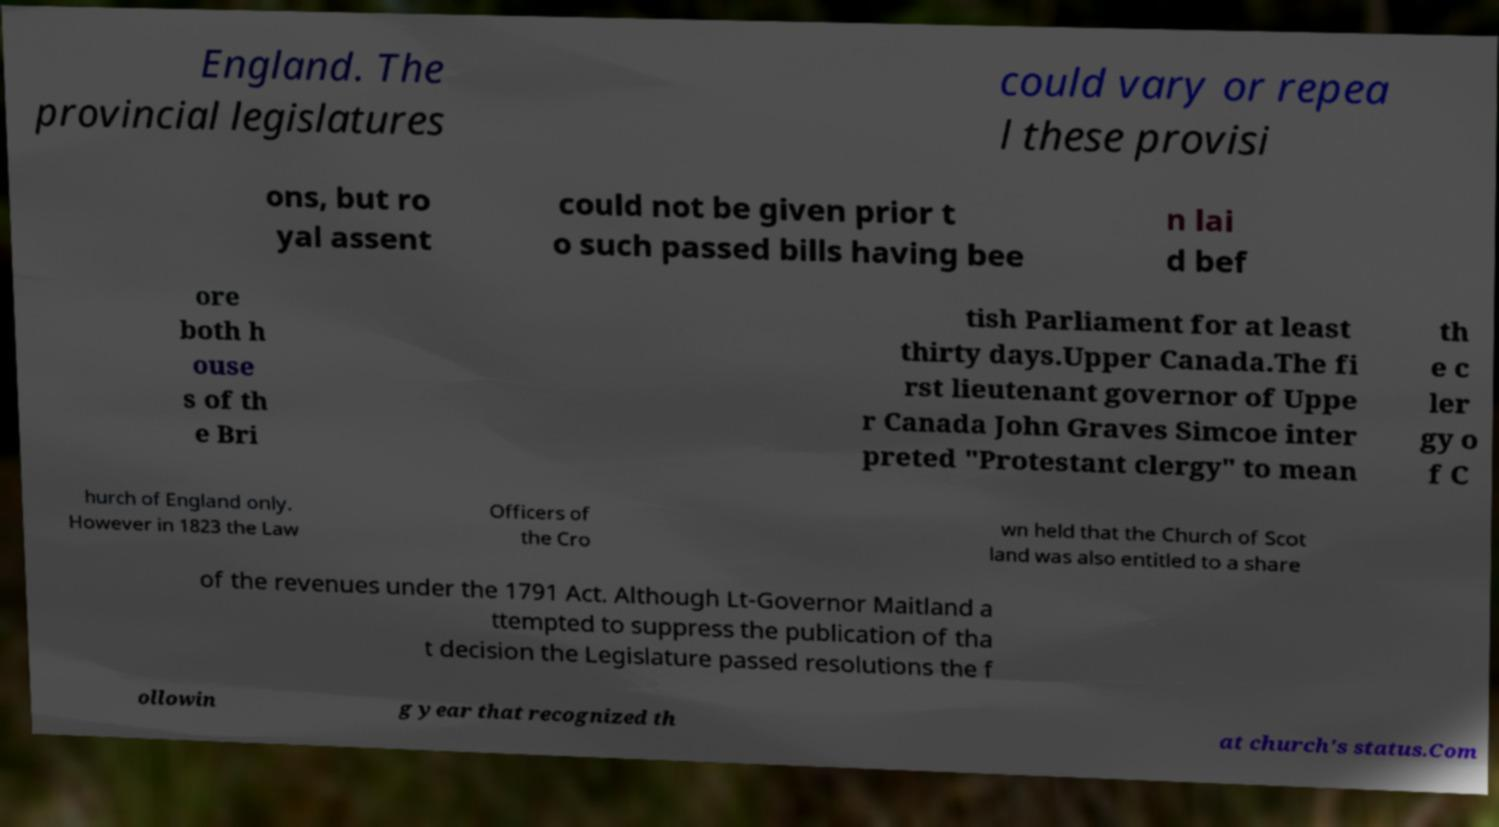I need the written content from this picture converted into text. Can you do that? England. The provincial legislatures could vary or repea l these provisi ons, but ro yal assent could not be given prior t o such passed bills having bee n lai d bef ore both h ouse s of th e Bri tish Parliament for at least thirty days.Upper Canada.The fi rst lieutenant governor of Uppe r Canada John Graves Simcoe inter preted "Protestant clergy" to mean th e c ler gy o f C hurch of England only. However in 1823 the Law Officers of the Cro wn held that the Church of Scot land was also entitled to a share of the revenues under the 1791 Act. Although Lt-Governor Maitland a ttempted to suppress the publication of tha t decision the Legislature passed resolutions the f ollowin g year that recognized th at church's status.Com 